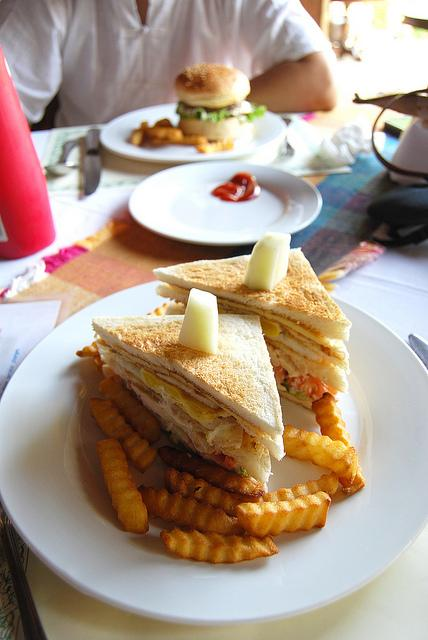What is used the make the fries have that shape? machine 